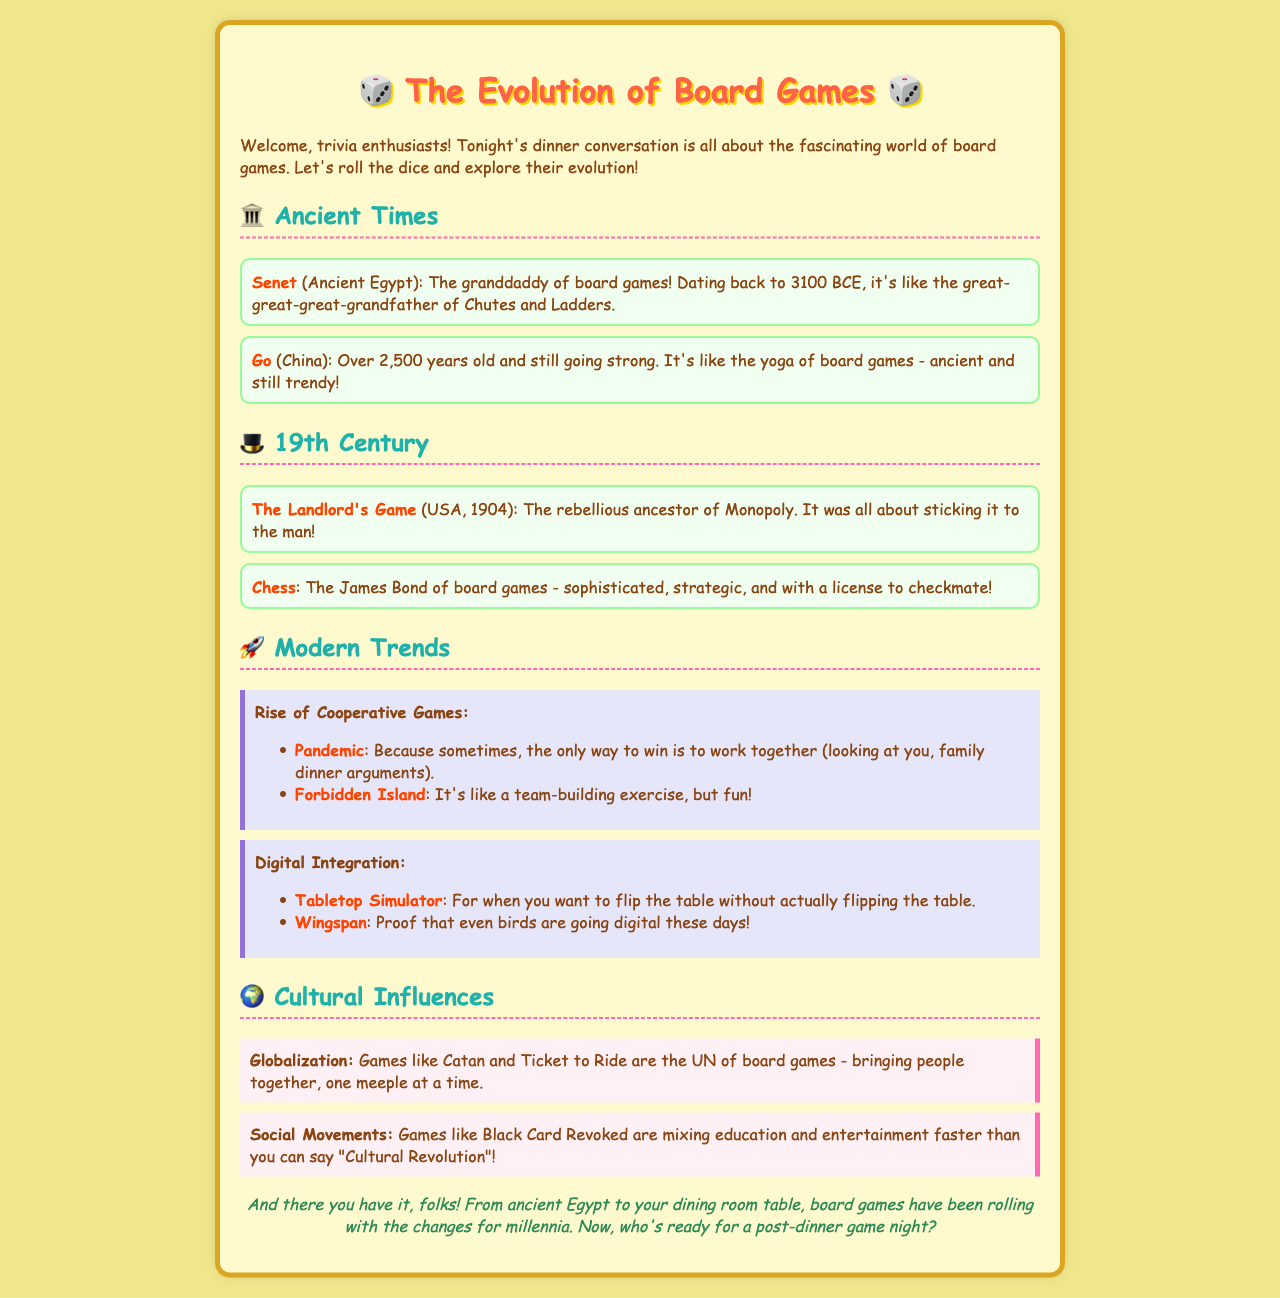What is the oldest known board game? The document states that Senet is the granddaddy of board games, dating back to 3100 BCE.
Answer: Senet Which board game is referred to as the James Bond of board games? According to the document, Chess is characterized as sophisticated and strategic, likening it to James Bond.
Answer: Chess What year was The Landlord's Game created? The document mentions that The Landlord's Game was created in the USA in 1904.
Answer: 1904 Which cooperative game is mentioned as exemplifying teamwork? The text specifically highlights Pandemic as a game where the only way to win is to work together.
Answer: Pandemic What cultural influence is described as mixing education and entertainment? The document states that Black Card Revoked combines education and entertainment, tied to social movements.
Answer: Social Movements How many years old is the board game Go? The document indicates that Go is over 2,500 years old.
Answer: 2500 Which modern trend involves integrating digital elements into board games? The document lists Digital Integration as a modern trend affecting board games today.
Answer: Digital Integration What is described as the UN of board games? Catan and Ticket to Ride are referenced as games that bring people together, similar to the UN.
Answer: Catan and Ticket to Ride What is the conclusion about the evolution of board games? The document concludes that board games have been rolling with the changes for millennia, from ancient Egypt to the dining room table.
Answer: Rolling with the changes for millennia 